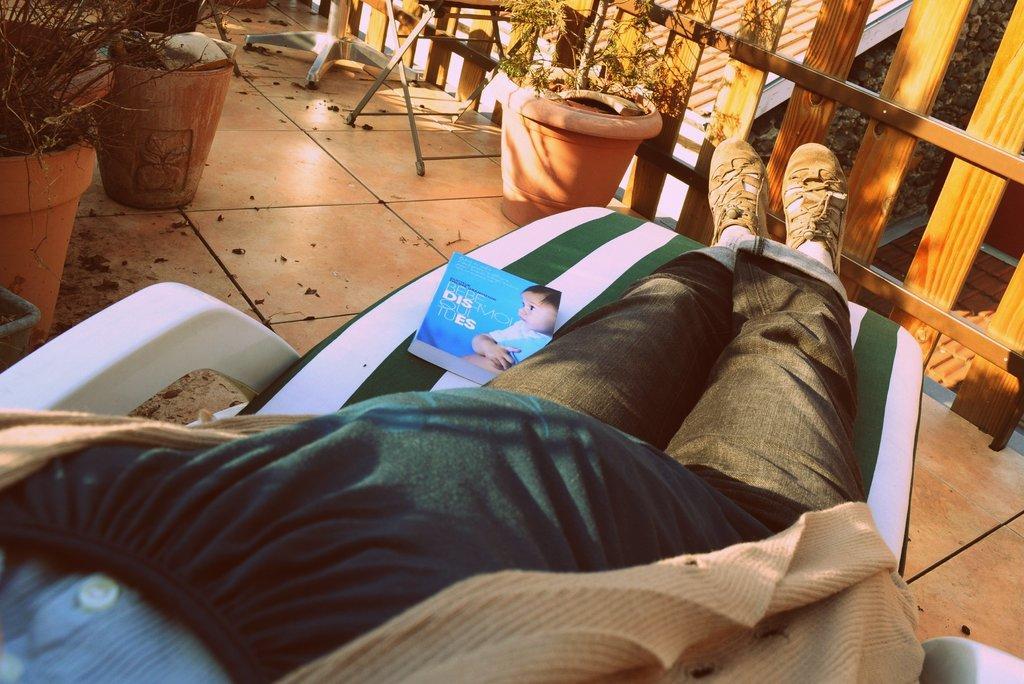How would you summarize this image in a sentence or two? In this picture we can see plants, pots, objects, floor, wooden railing. We can see partial part of a person. Person is resting on a chair. On a chair we can see a magazine. 